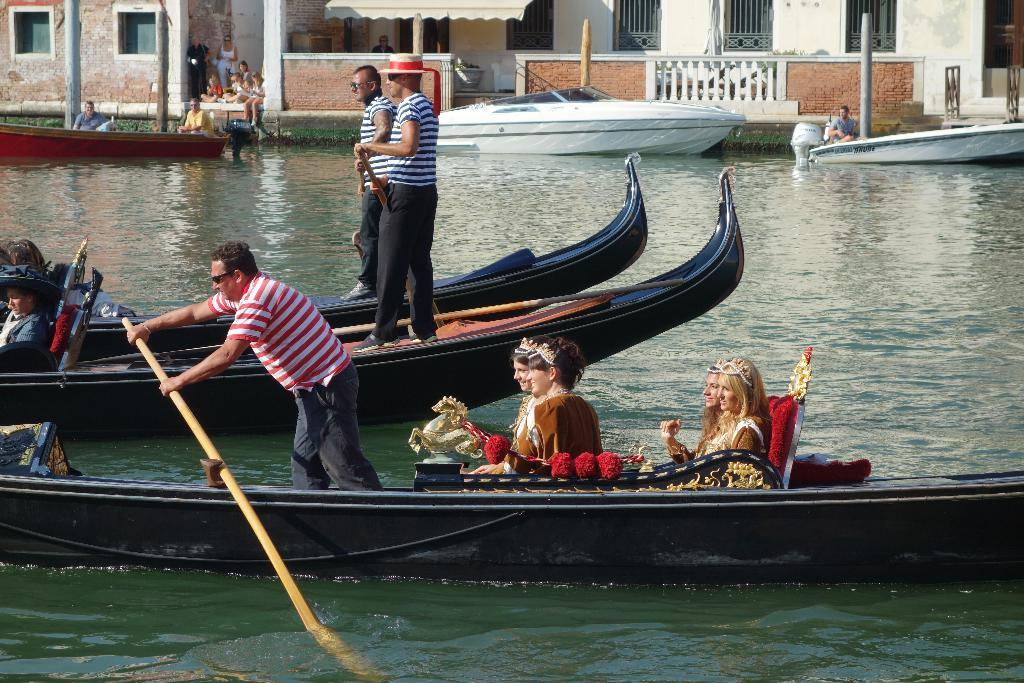What is the primary element in the image? There is water in the image. What is on the water in the image? There are boats on the water. Who is in the boats in the image? There are people in the boats. What can be seen in the background of the image? There are buildings and people visible in the background of the image. What type of game is being played by the people in the boats in the image? There is no indication of a game being played in the image; people are simply in the boats on the water. 